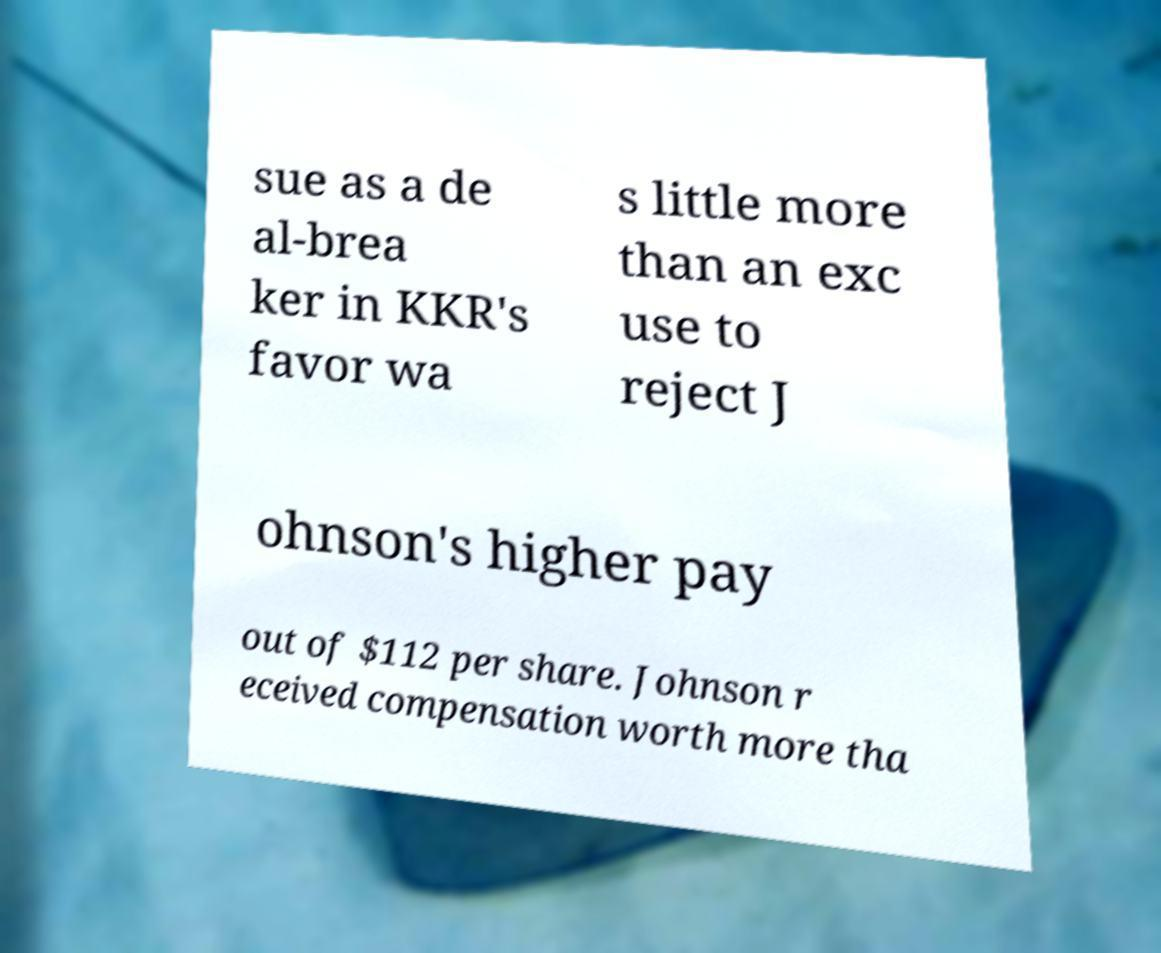There's text embedded in this image that I need extracted. Can you transcribe it verbatim? sue as a de al-brea ker in KKR's favor wa s little more than an exc use to reject J ohnson's higher pay out of $112 per share. Johnson r eceived compensation worth more tha 